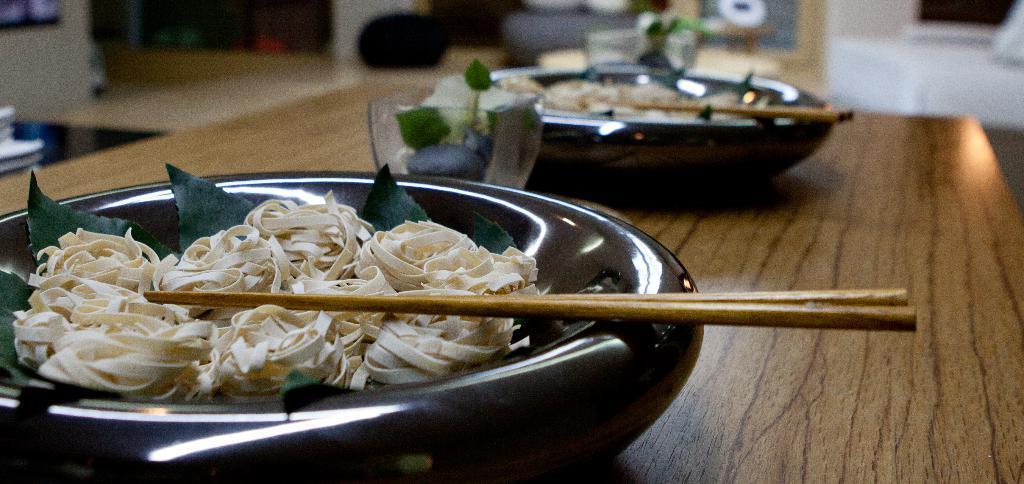Can you describe this image briefly? We can see bowls,sticks,food,glass on the table. 